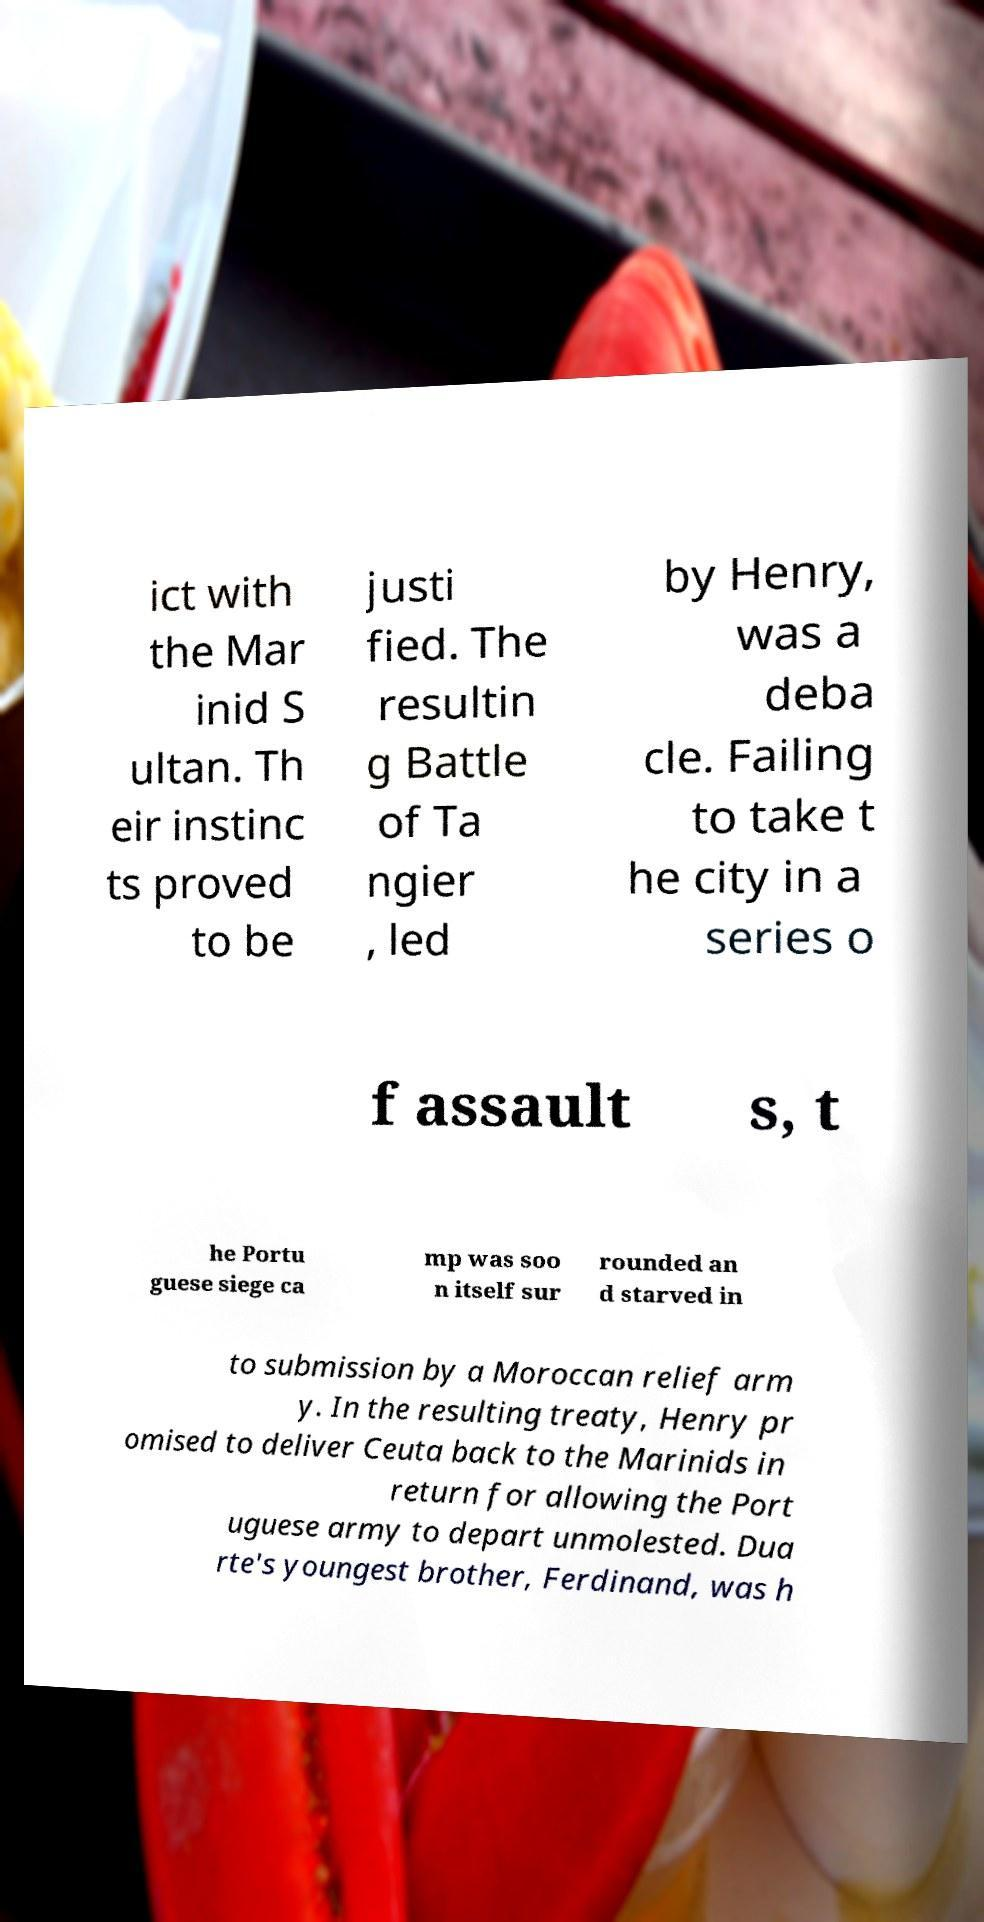Can you accurately transcribe the text from the provided image for me? ict with the Mar inid S ultan. Th eir instinc ts proved to be justi fied. The resultin g Battle of Ta ngier , led by Henry, was a deba cle. Failing to take t he city in a series o f assault s, t he Portu guese siege ca mp was soo n itself sur rounded an d starved in to submission by a Moroccan relief arm y. In the resulting treaty, Henry pr omised to deliver Ceuta back to the Marinids in return for allowing the Port uguese army to depart unmolested. Dua rte's youngest brother, Ferdinand, was h 